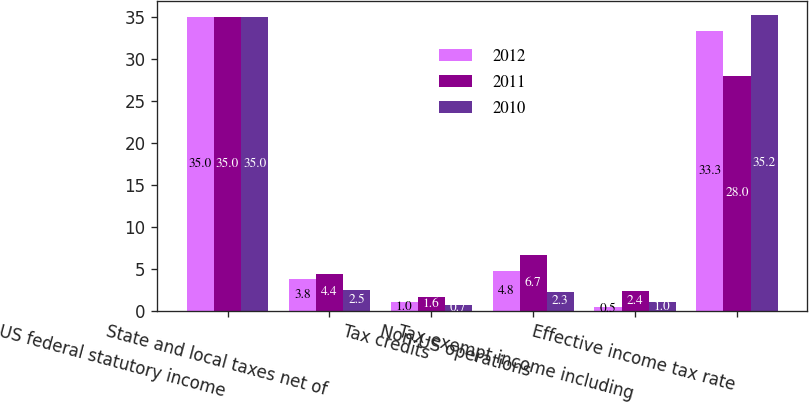Convert chart. <chart><loc_0><loc_0><loc_500><loc_500><stacked_bar_chart><ecel><fcel>US federal statutory income<fcel>State and local taxes net of<fcel>Tax credits<fcel>Non-US operations<fcel>Tax-exempt income including<fcel>Effective income tax rate<nl><fcel>2012<fcel>35<fcel>3.8<fcel>1<fcel>4.8<fcel>0.5<fcel>33.3<nl><fcel>2011<fcel>35<fcel>4.4<fcel>1.6<fcel>6.7<fcel>2.4<fcel>28<nl><fcel>2010<fcel>35<fcel>2.5<fcel>0.7<fcel>2.3<fcel>1<fcel>35.2<nl></chart> 